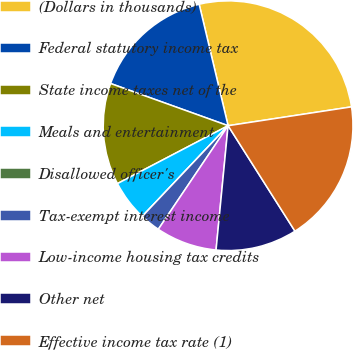<chart> <loc_0><loc_0><loc_500><loc_500><pie_chart><fcel>(Dollars in thousands)<fcel>Federal statutory income tax<fcel>State income taxes net of the<fcel>Meals and entertainment<fcel>Disallowed officer's<fcel>Tax-exempt interest income<fcel>Low-income housing tax credits<fcel>Other net<fcel>Effective income tax rate (1)<nl><fcel>26.31%<fcel>15.79%<fcel>13.16%<fcel>5.26%<fcel>0.0%<fcel>2.63%<fcel>7.9%<fcel>10.53%<fcel>18.42%<nl></chart> 